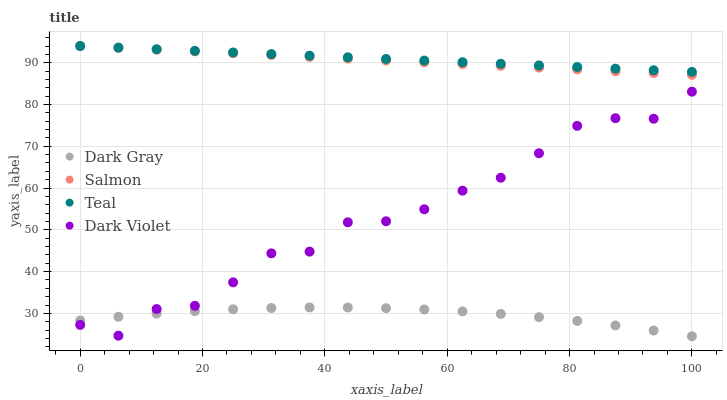Does Dark Gray have the minimum area under the curve?
Answer yes or no. Yes. Does Teal have the maximum area under the curve?
Answer yes or no. Yes. Does Salmon have the minimum area under the curve?
Answer yes or no. No. Does Salmon have the maximum area under the curve?
Answer yes or no. No. Is Teal the smoothest?
Answer yes or no. Yes. Is Dark Violet the roughest?
Answer yes or no. Yes. Is Salmon the smoothest?
Answer yes or no. No. Is Salmon the roughest?
Answer yes or no. No. Does Dark Gray have the lowest value?
Answer yes or no. Yes. Does Salmon have the lowest value?
Answer yes or no. No. Does Teal have the highest value?
Answer yes or no. Yes. Does Dark Violet have the highest value?
Answer yes or no. No. Is Dark Violet less than Teal?
Answer yes or no. Yes. Is Teal greater than Dark Violet?
Answer yes or no. Yes. Does Teal intersect Salmon?
Answer yes or no. Yes. Is Teal less than Salmon?
Answer yes or no. No. Is Teal greater than Salmon?
Answer yes or no. No. Does Dark Violet intersect Teal?
Answer yes or no. No. 